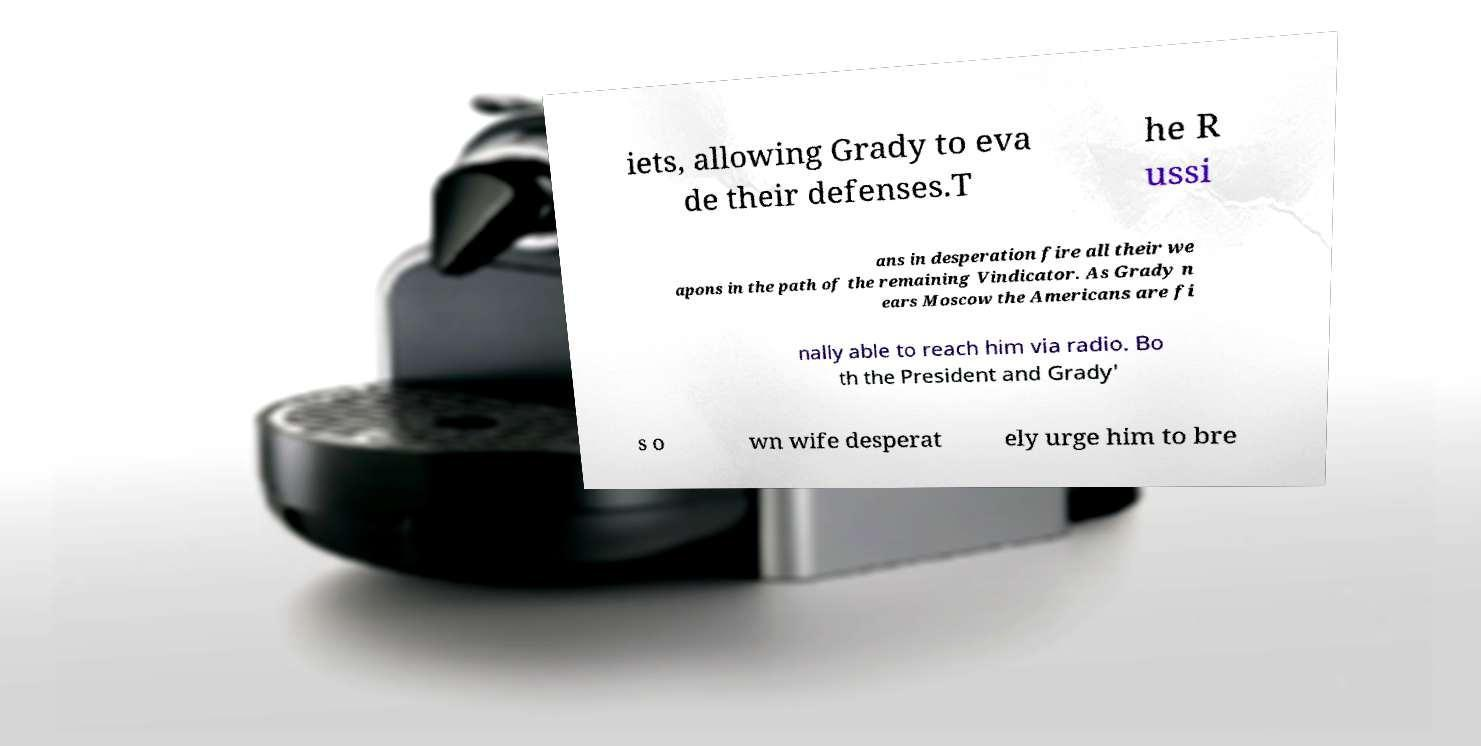What messages or text are displayed in this image? I need them in a readable, typed format. iets, allowing Grady to eva de their defenses.T he R ussi ans in desperation fire all their we apons in the path of the remaining Vindicator. As Grady n ears Moscow the Americans are fi nally able to reach him via radio. Bo th the President and Grady' s o wn wife desperat ely urge him to bre 